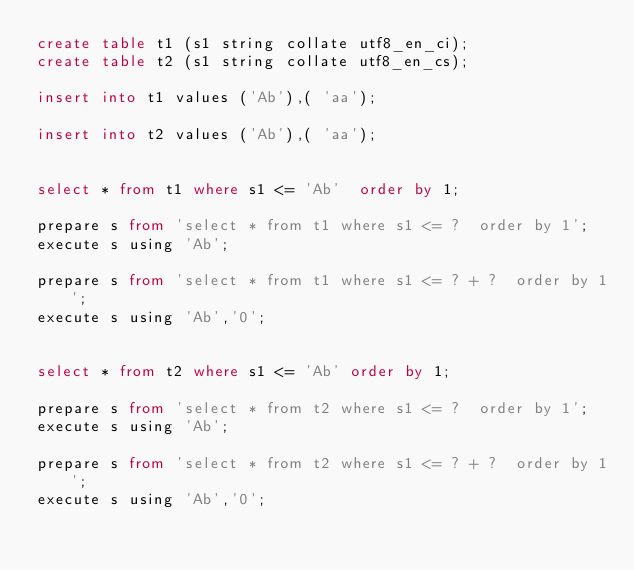Convert code to text. <code><loc_0><loc_0><loc_500><loc_500><_SQL_>create table t1 (s1 string collate utf8_en_ci);
create table t2 (s1 string collate utf8_en_cs);

insert into t1 values ('Ab'),( 'aa');

insert into t2 values ('Ab'),( 'aa');


select * from t1 where s1 <= 'Ab'  order by 1;

prepare s from 'select * from t1 where s1 <= ?  order by 1';
execute s using 'Ab';

prepare s from 'select * from t1 where s1 <= ? + ?  order by 1';
execute s using 'Ab','0';


select * from t2 where s1 <= 'Ab' order by 1;

prepare s from 'select * from t2 where s1 <= ?  order by 1';
execute s using 'Ab';

prepare s from 'select * from t2 where s1 <= ? + ?  order by 1';
execute s using 'Ab','0';
</code> 